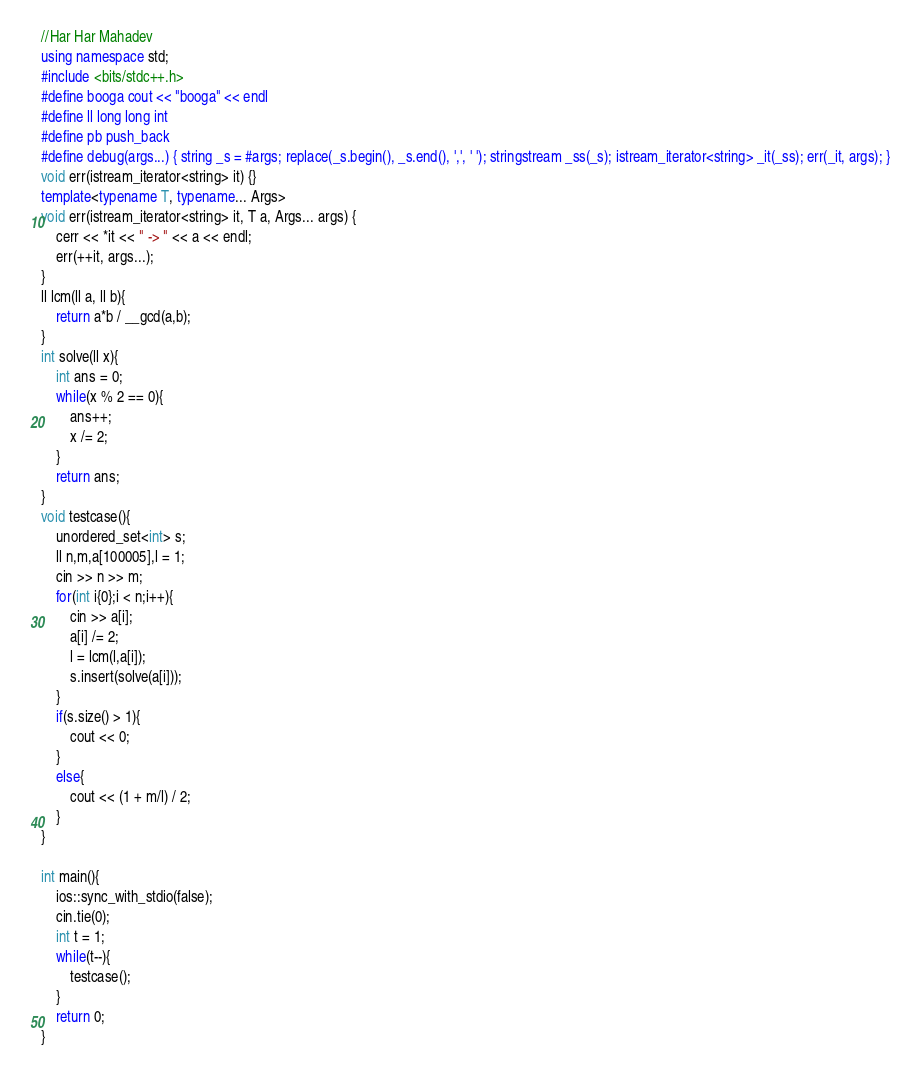<code> <loc_0><loc_0><loc_500><loc_500><_C++_>//Har Har Mahadev
using namespace std;
#include <bits/stdc++.h>
#define booga cout << "booga" << endl
#define ll long long int
#define pb push_back
#define debug(args...) { string _s = #args; replace(_s.begin(), _s.end(), ',', ' '); stringstream _ss(_s); istream_iterator<string> _it(_ss); err(_it, args); }
void err(istream_iterator<string> it) {}
template<typename T, typename... Args>
void err(istream_iterator<string> it, T a, Args... args) {
	cerr << *it << " -> " << a << endl;
	err(++it, args...);
}
ll lcm(ll a, ll b){
	return a*b / __gcd(a,b);
}
int solve(ll x){
	int ans = 0;
	while(x % 2 == 0){
		ans++;
		x /= 2;
	}
	return ans;
}
void testcase(){
	unordered_set<int> s;
	ll n,m,a[100005],l = 1;
	cin >> n >> m;
	for(int i{0};i < n;i++){
		cin >> a[i];
		a[i] /= 2;
		l = lcm(l,a[i]);
		s.insert(solve(a[i]));
	}
	if(s.size() > 1){
		cout << 0;
	}
	else{
		cout << (1 + m/l) / 2;
	}
}

int main(){
	ios::sync_with_stdio(false);
	cin.tie(0);
	int t = 1;
	while(t--){
		testcase();
	}
	return 0;
}
</code> 